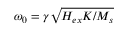Convert formula to latex. <formula><loc_0><loc_0><loc_500><loc_500>\omega _ { 0 } = \gamma \sqrt { H _ { e x } K / M _ { s } }</formula> 